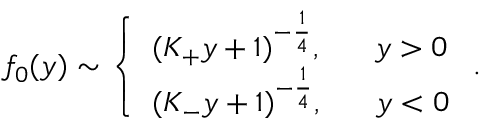Convert formula to latex. <formula><loc_0><loc_0><loc_500><loc_500>f _ { 0 } ( y ) \sim \left \{ \begin{array} { l } { { ( K _ { + } y + 1 ) ^ { - { \frac { 1 } { 4 } } } , \quad \ y > 0 } } \\ { { ( K _ { - } y + 1 ) ^ { - { \frac { 1 } { 4 } } } , \quad \ y < 0 } } \end{array} .</formula> 